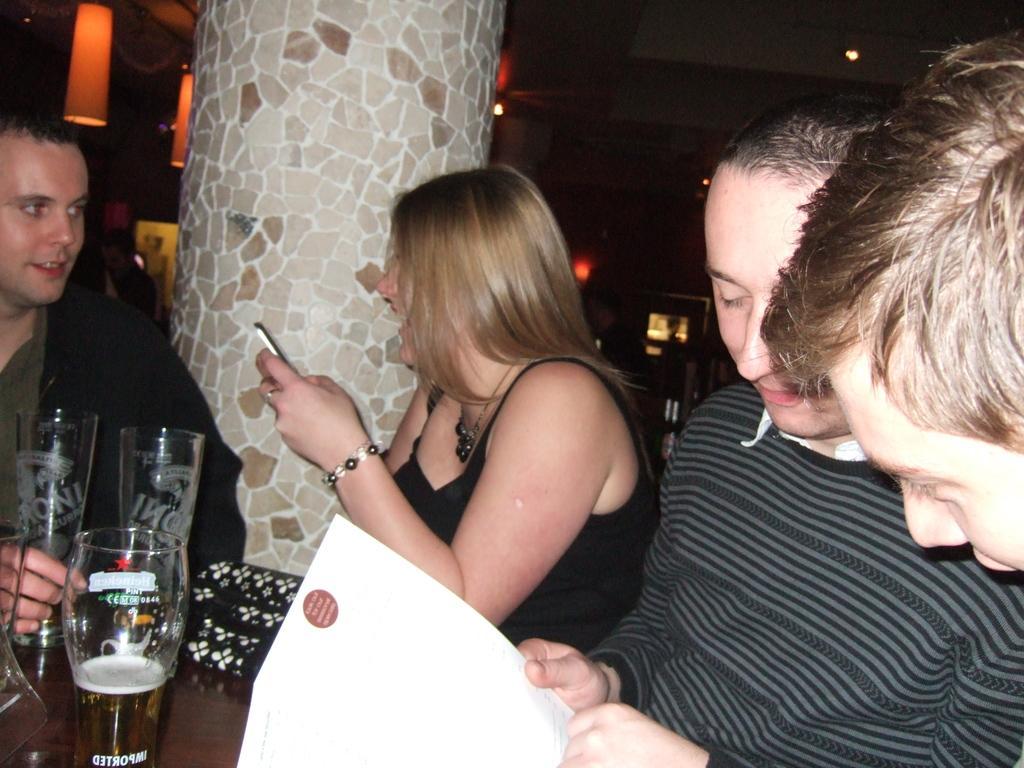Please provide a concise description of this image. In this picture we can see four persons where a woman is holding a mobile with her hand and smiling and in front of them on table we can see glasses and in the background we can see a pillar, lights. 